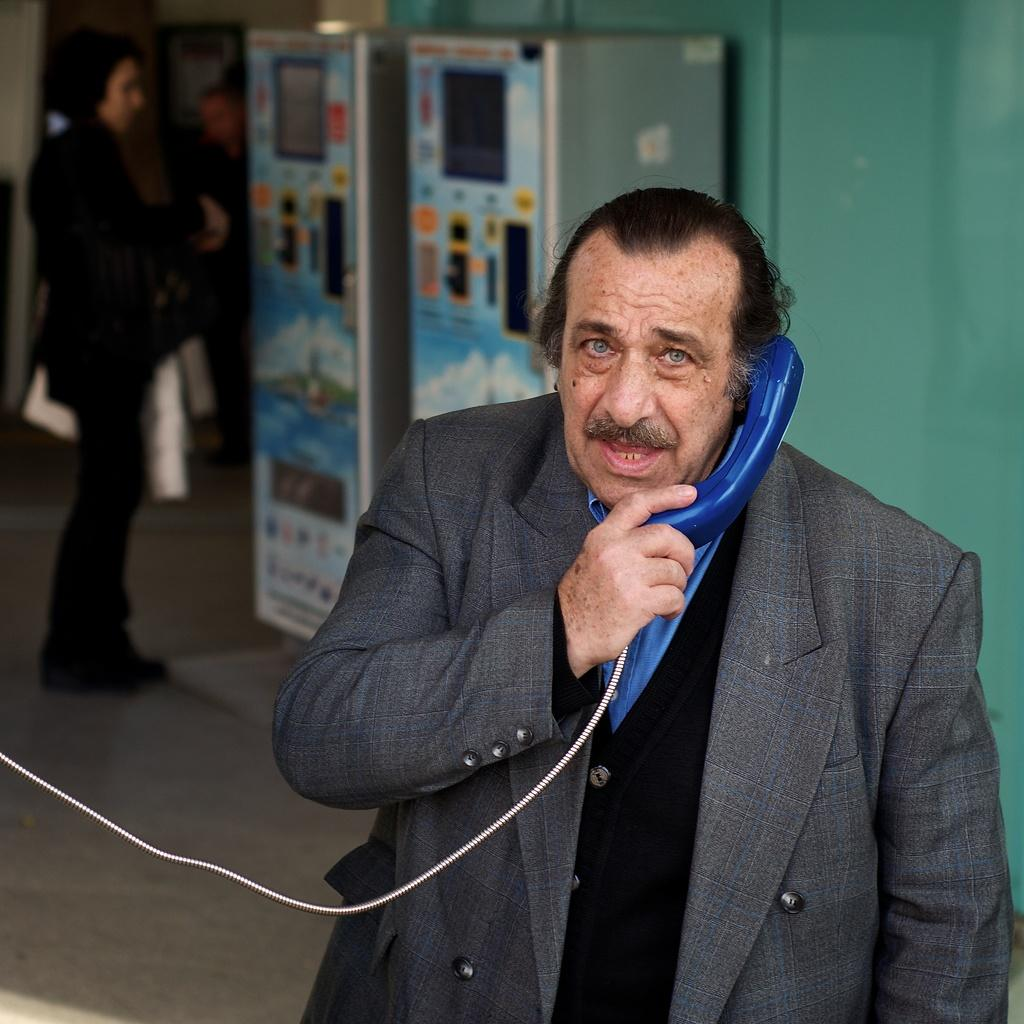What can be found on the shelf in the image? There are items in the shelf in the image. Where is the kid located in the image? The kid is on the left side of the image. Can you see a goldfish swimming in the image? There is no goldfish present in the image. Is there a mountain visible in the background of the image? There is no mountain visible in the image. 